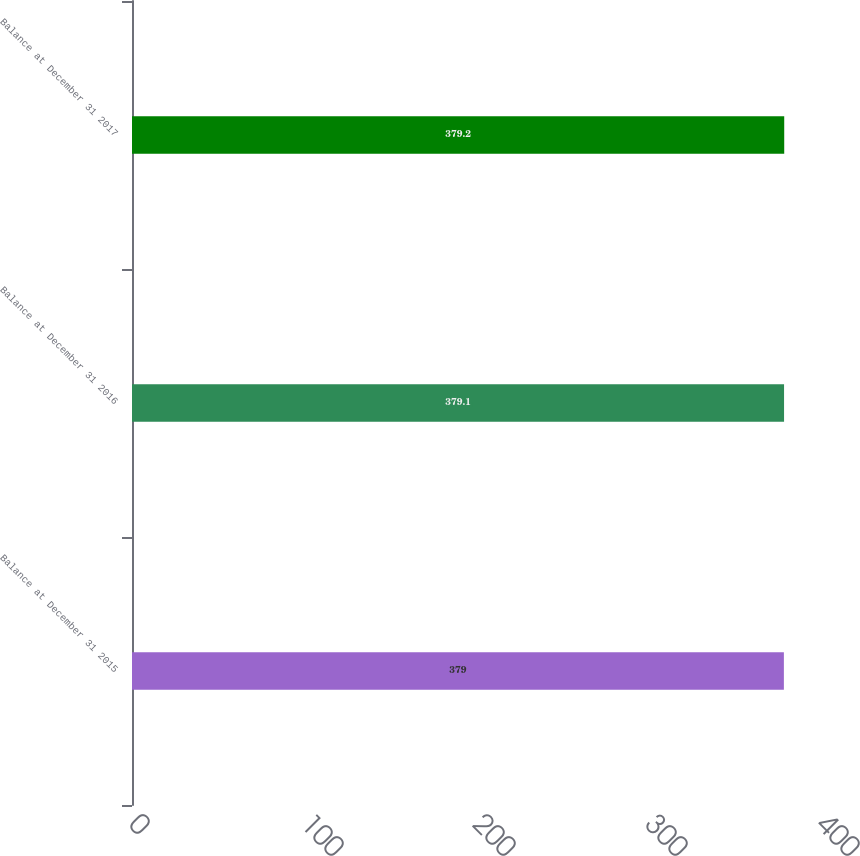Convert chart. <chart><loc_0><loc_0><loc_500><loc_500><bar_chart><fcel>Balance at December 31 2015<fcel>Balance at December 31 2016<fcel>Balance at December 31 2017<nl><fcel>379<fcel>379.1<fcel>379.2<nl></chart> 